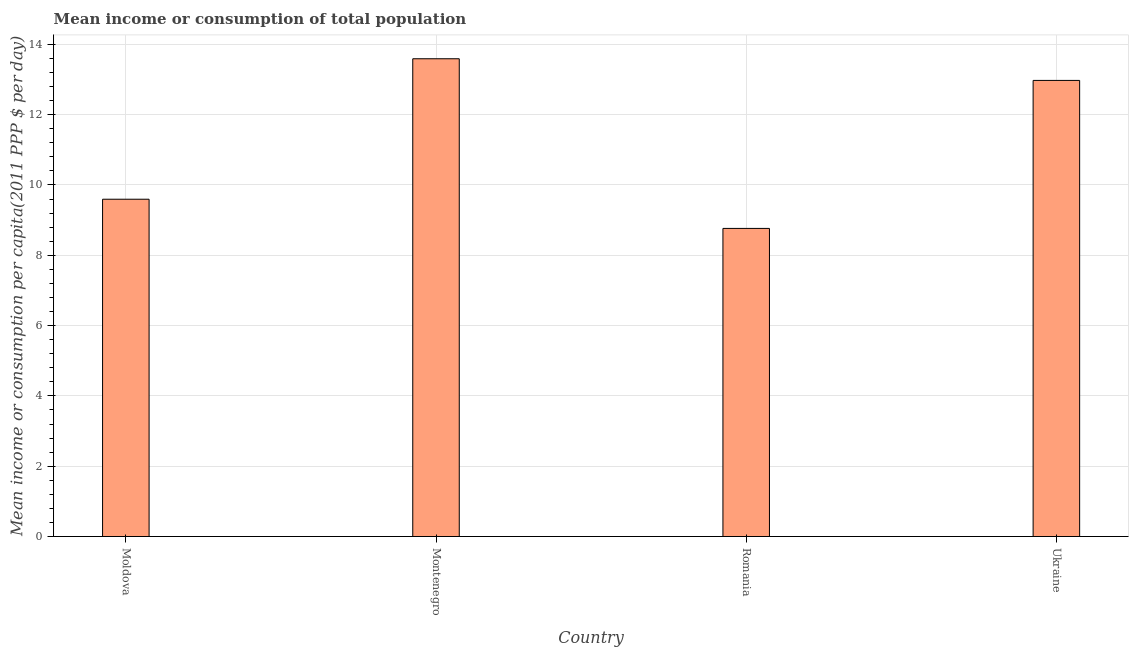Does the graph contain grids?
Your response must be concise. Yes. What is the title of the graph?
Ensure brevity in your answer.  Mean income or consumption of total population. What is the label or title of the X-axis?
Make the answer very short. Country. What is the label or title of the Y-axis?
Provide a short and direct response. Mean income or consumption per capita(2011 PPP $ per day). What is the mean income or consumption in Moldova?
Offer a very short reply. 9.59. Across all countries, what is the maximum mean income or consumption?
Offer a very short reply. 13.59. Across all countries, what is the minimum mean income or consumption?
Ensure brevity in your answer.  8.76. In which country was the mean income or consumption maximum?
Ensure brevity in your answer.  Montenegro. In which country was the mean income or consumption minimum?
Make the answer very short. Romania. What is the sum of the mean income or consumption?
Keep it short and to the point. 44.92. What is the difference between the mean income or consumption in Moldova and Montenegro?
Offer a very short reply. -4. What is the average mean income or consumption per country?
Your answer should be compact. 11.23. What is the median mean income or consumption?
Your answer should be compact. 11.28. In how many countries, is the mean income or consumption greater than 8.8 $?
Give a very brief answer. 3. What is the ratio of the mean income or consumption in Montenegro to that in Ukraine?
Offer a terse response. 1.05. Is the mean income or consumption in Moldova less than that in Romania?
Offer a very short reply. No. What is the difference between the highest and the second highest mean income or consumption?
Make the answer very short. 0.62. What is the difference between the highest and the lowest mean income or consumption?
Keep it short and to the point. 4.83. What is the difference between two consecutive major ticks on the Y-axis?
Your response must be concise. 2. What is the Mean income or consumption per capita(2011 PPP $ per day) in Moldova?
Ensure brevity in your answer.  9.59. What is the Mean income or consumption per capita(2011 PPP $ per day) in Montenegro?
Ensure brevity in your answer.  13.59. What is the Mean income or consumption per capita(2011 PPP $ per day) in Romania?
Offer a terse response. 8.76. What is the Mean income or consumption per capita(2011 PPP $ per day) of Ukraine?
Make the answer very short. 12.97. What is the difference between the Mean income or consumption per capita(2011 PPP $ per day) in Moldova and Montenegro?
Offer a very short reply. -4. What is the difference between the Mean income or consumption per capita(2011 PPP $ per day) in Moldova and Romania?
Provide a succinct answer. 0.83. What is the difference between the Mean income or consumption per capita(2011 PPP $ per day) in Moldova and Ukraine?
Give a very brief answer. -3.38. What is the difference between the Mean income or consumption per capita(2011 PPP $ per day) in Montenegro and Romania?
Offer a very short reply. 4.83. What is the difference between the Mean income or consumption per capita(2011 PPP $ per day) in Montenegro and Ukraine?
Offer a terse response. 0.62. What is the difference between the Mean income or consumption per capita(2011 PPP $ per day) in Romania and Ukraine?
Make the answer very short. -4.21. What is the ratio of the Mean income or consumption per capita(2011 PPP $ per day) in Moldova to that in Montenegro?
Your response must be concise. 0.71. What is the ratio of the Mean income or consumption per capita(2011 PPP $ per day) in Moldova to that in Romania?
Ensure brevity in your answer.  1.09. What is the ratio of the Mean income or consumption per capita(2011 PPP $ per day) in Moldova to that in Ukraine?
Your response must be concise. 0.74. What is the ratio of the Mean income or consumption per capita(2011 PPP $ per day) in Montenegro to that in Romania?
Offer a very short reply. 1.55. What is the ratio of the Mean income or consumption per capita(2011 PPP $ per day) in Montenegro to that in Ukraine?
Provide a succinct answer. 1.05. What is the ratio of the Mean income or consumption per capita(2011 PPP $ per day) in Romania to that in Ukraine?
Keep it short and to the point. 0.68. 